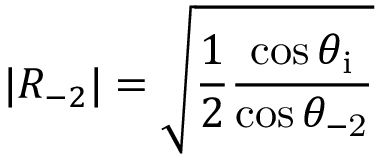Convert formula to latex. <formula><loc_0><loc_0><loc_500><loc_500>| R _ { - 2 } | = \sqrt { \frac { 1 } { 2 } \frac { \cos { \theta _ { i } } } { \cos { \theta _ { - 2 } } } }</formula> 